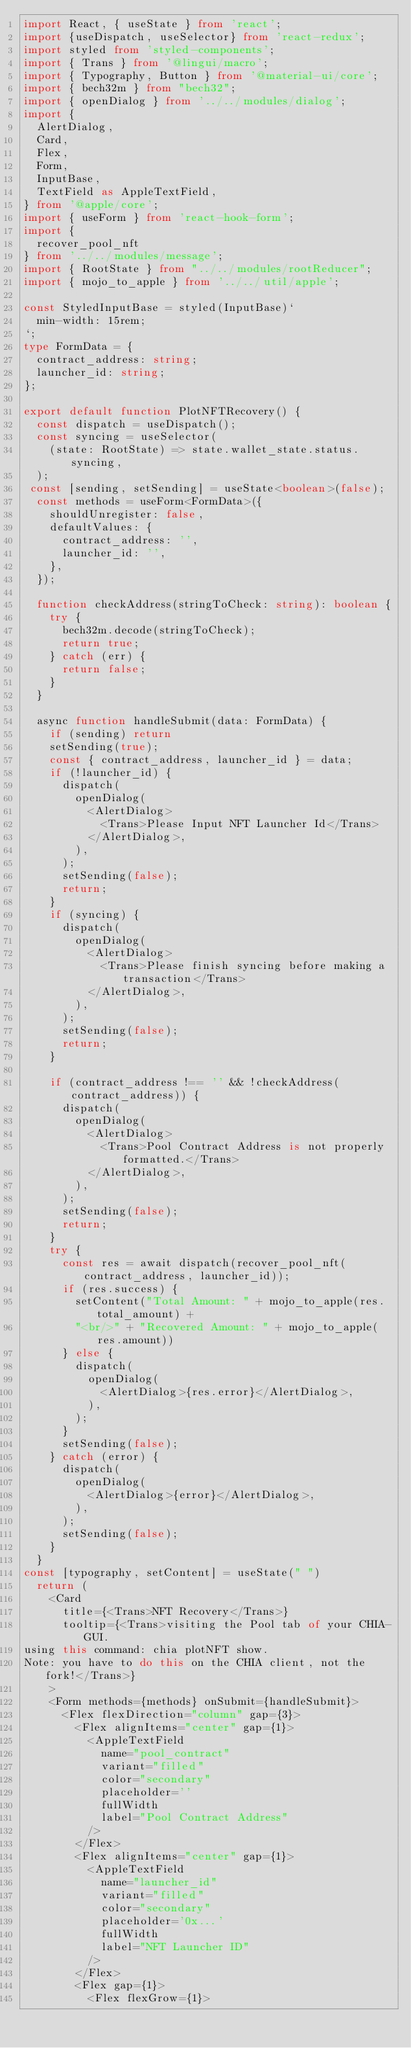<code> <loc_0><loc_0><loc_500><loc_500><_TypeScript_>import React, { useState } from 'react';
import {useDispatch, useSelector} from 'react-redux';
import styled from 'styled-components';
import { Trans } from '@lingui/macro';
import { Typography, Button } from '@material-ui/core';
import { bech32m } from "bech32";
import { openDialog } from '../../modules/dialog';
import {
  AlertDialog,
  Card,
  Flex,
  Form,
  InputBase,
  TextField as AppleTextField,
} from '@apple/core';
import { useForm } from 'react-hook-form';
import {
  recover_pool_nft
} from '../../modules/message';
import { RootState } from "../../modules/rootReducer";
import { mojo_to_apple } from '../../util/apple';

const StyledInputBase = styled(InputBase)`
  min-width: 15rem;
`;
type FormData = {
  contract_address: string;
  launcher_id: string;
};

export default function PlotNFTRecovery() {
  const dispatch = useDispatch();
  const syncing = useSelector(
    (state: RootState) => state.wallet_state.status.syncing,
  );
 const [sending, setSending] = useState<boolean>(false);
  const methods = useForm<FormData>({
    shouldUnregister: false,
    defaultValues: {
      contract_address: '',
      launcher_id: '',
    },
  });

  function checkAddress(stringToCheck: string): boolean {
    try {
      bech32m.decode(stringToCheck);
      return true;
    } catch (err) {
      return false;
    }
  }

  async function handleSubmit(data: FormData) {
    if (sending) return
    setSending(true);
    const { contract_address, launcher_id } = data;
    if (!launcher_id) {
      dispatch(
        openDialog(
          <AlertDialog>
            <Trans>Please Input NFT Launcher Id</Trans>
          </AlertDialog>,
        ),
      );
      setSending(false);
      return;
    }
    if (syncing) {
      dispatch(
        openDialog(
          <AlertDialog>
            <Trans>Please finish syncing before making a transaction</Trans>
          </AlertDialog>,
        ),
      );
      setSending(false);
      return;
    }

    if (contract_address !== '' && !checkAddress(contract_address)) {
      dispatch(
        openDialog(
          <AlertDialog>
            <Trans>Pool Contract Address is not properly formatted.</Trans>
          </AlertDialog>,
        ),
      );
      setSending(false);
      return;
    }
    try {
      const res = await dispatch(recover_pool_nft(contract_address, launcher_id));
      if (res.success) {
        setContent("Total Amount: " + mojo_to_apple(res.total_amount) +
        "<br/>" + "Recovered Amount: " + mojo_to_apple(res.amount))
      } else {
        dispatch(
          openDialog(
            <AlertDialog>{res.error}</AlertDialog>,
          ),
        );
      }
      setSending(false);
    } catch (error) {
      dispatch(
        openDialog(
          <AlertDialog>{error}</AlertDialog>,
        ),
      );
      setSending(false);
    }
  }
const [typography, setContent] = useState(" ")
  return (
    <Card
      title={<Trans>NFT Recovery</Trans>}
      tooltip={<Trans>visiting the Pool tab of your CHIA-GUI.
using this command: chia plotNFT show.
Note: you have to do this on the CHIA client, not the fork!</Trans>}
    >
    <Form methods={methods} onSubmit={handleSubmit}>
      <Flex flexDirection="column" gap={3}>
        <Flex alignItems="center" gap={1}>
          <AppleTextField
            name="pool_contract"
            variant="filled"
            color="secondary"
            placeholder=''
            fullWidth
            label="Pool Contract Address"
          />
        </Flex>
        <Flex alignItems="center" gap={1}>
          <AppleTextField
            name="launcher_id"
            variant="filled"
            color="secondary"
            placeholder='0x...'
            fullWidth
            label="NFT Launcher ID"
          />
        </Flex>
        <Flex gap={1}>
          <Flex flexGrow={1}></code> 